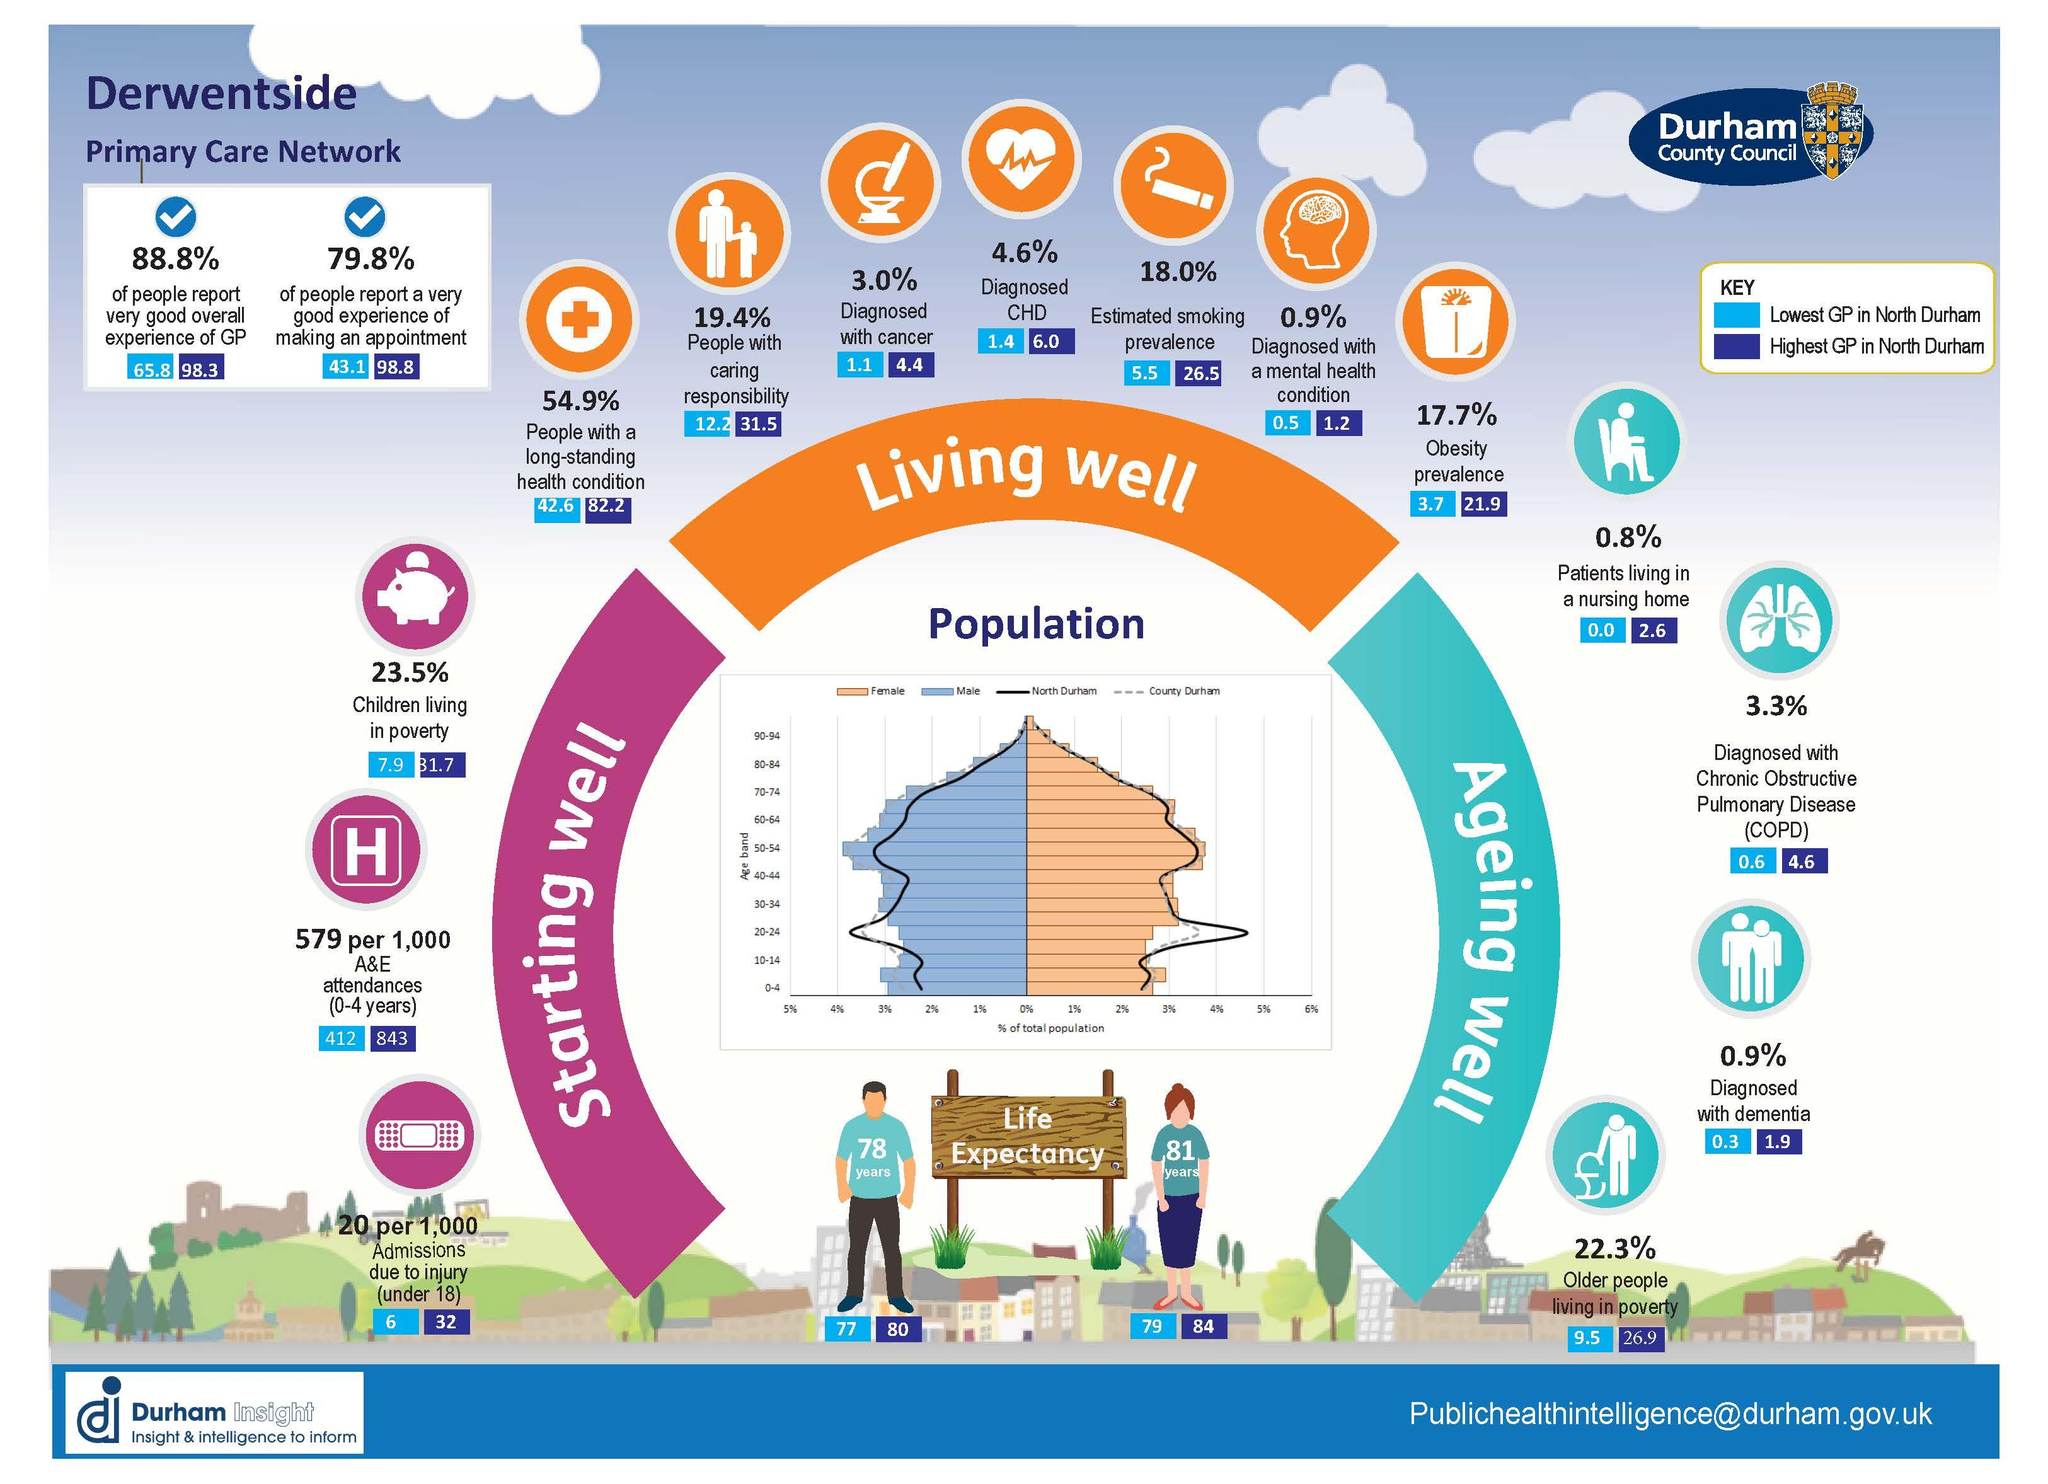Identify some key points in this picture. Lowest GP = General Practitioner (Primary Care Physician) According to the data provided, the average life expectancy for females in North Durham with the highest General Practitioner (GP) score is 84 years. In North Durham, there is a minimum GP level at which patients are residing in nursing homes, and that is 0.0. The color orange is traditionally associated with the concept of "living well. In North Durham, the life expectancy for males with the lowest GP is 77 years old. 